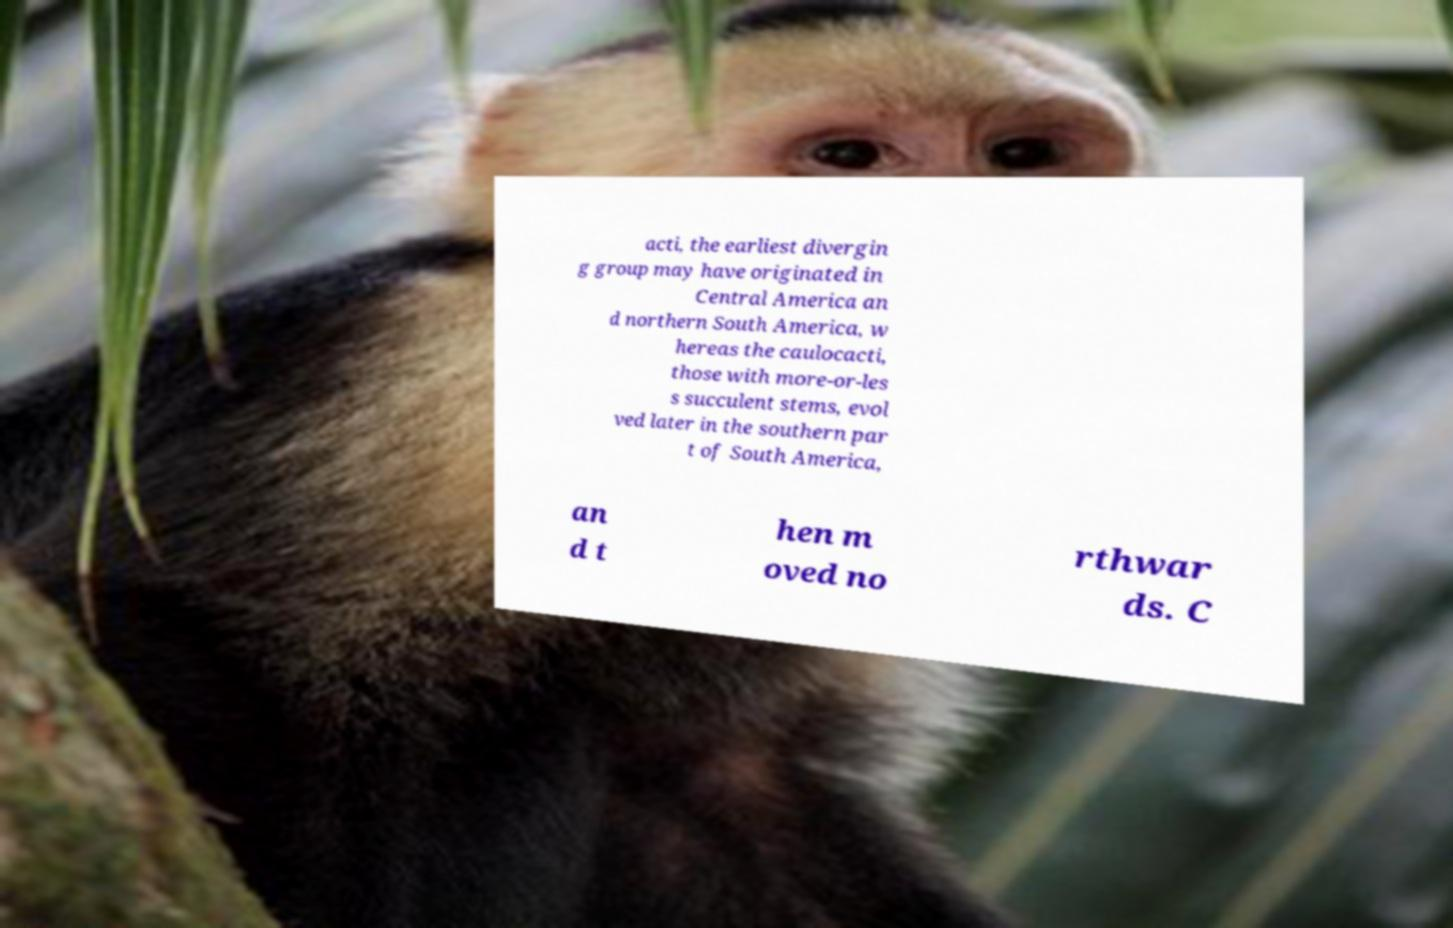Could you extract and type out the text from this image? acti, the earliest divergin g group may have originated in Central America an d northern South America, w hereas the caulocacti, those with more-or-les s succulent stems, evol ved later in the southern par t of South America, an d t hen m oved no rthwar ds. C 